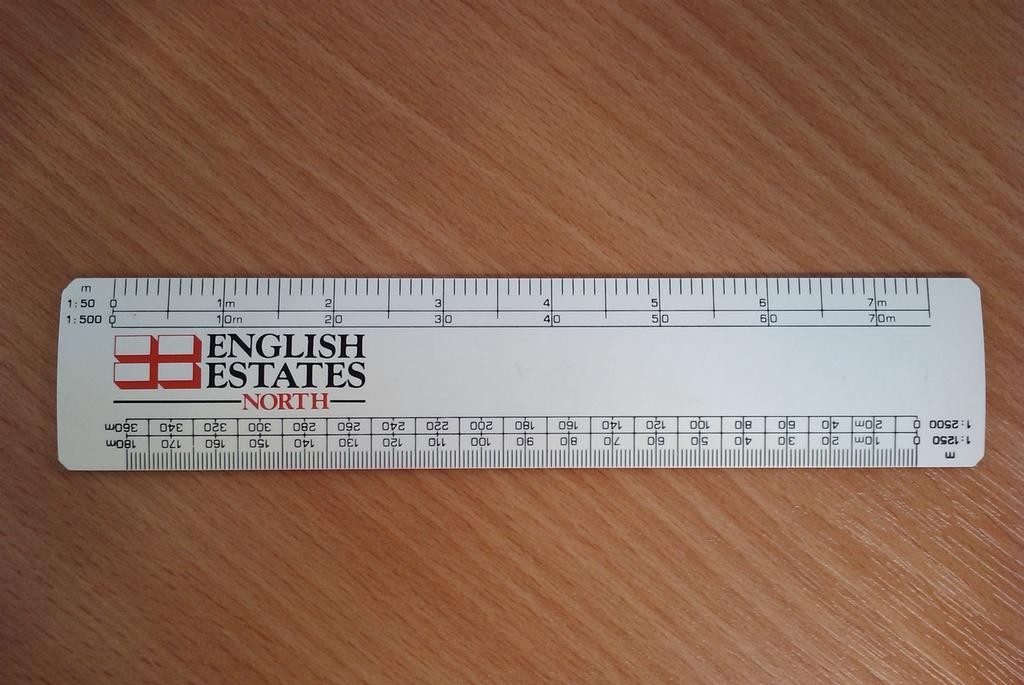<image>
Give a short and clear explanation of the subsequent image. A metric ruler with the logo English States North emblazoned upon it. 